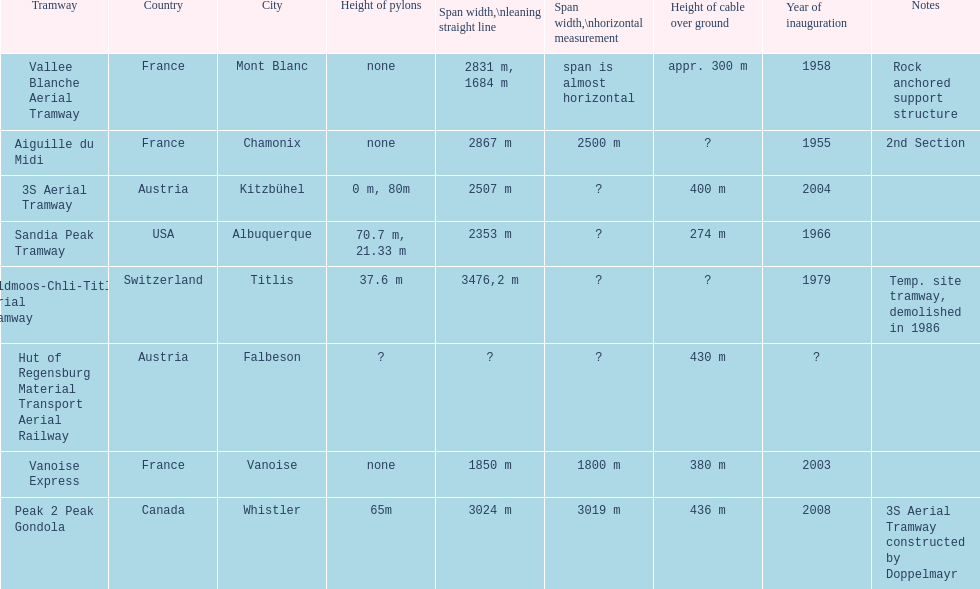How many aerial tramways are located in france? 3. 